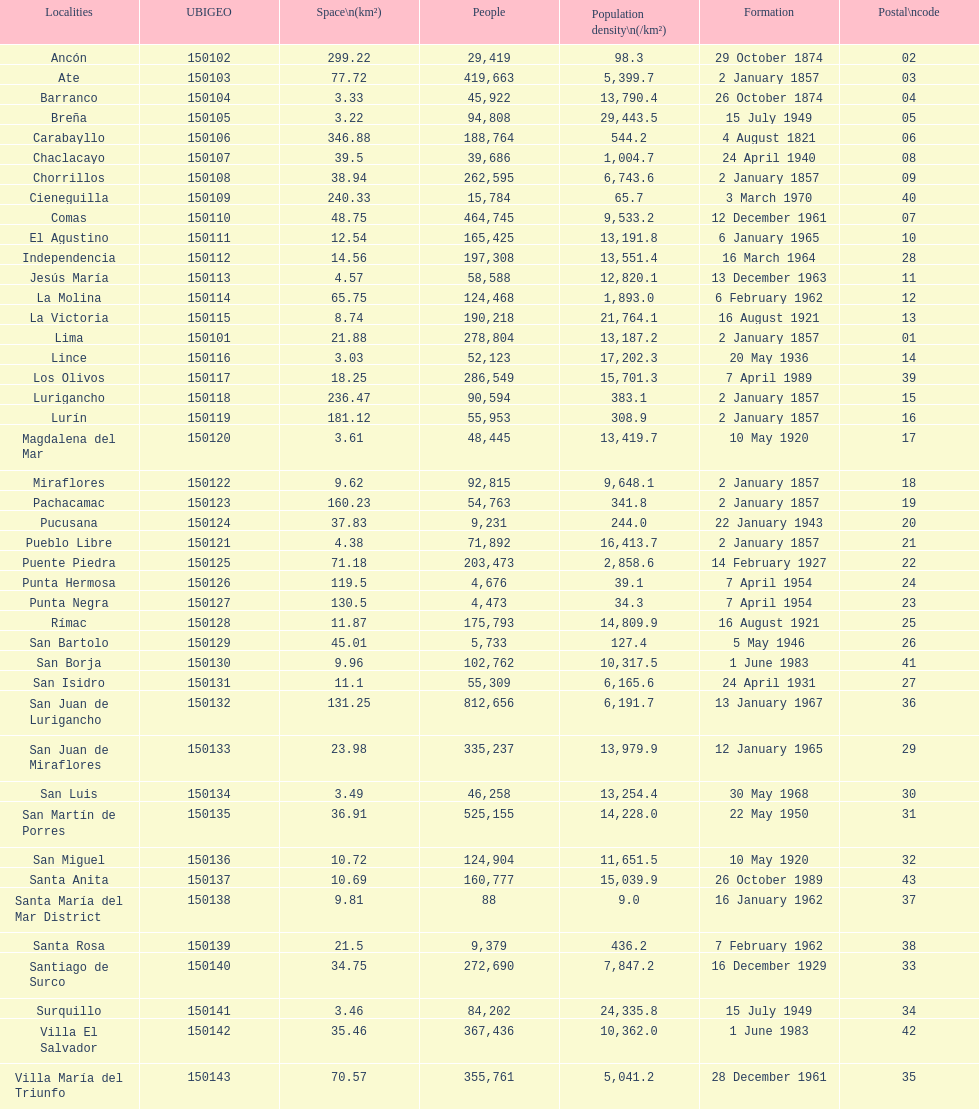What is the total number of districts of lima? 43. 